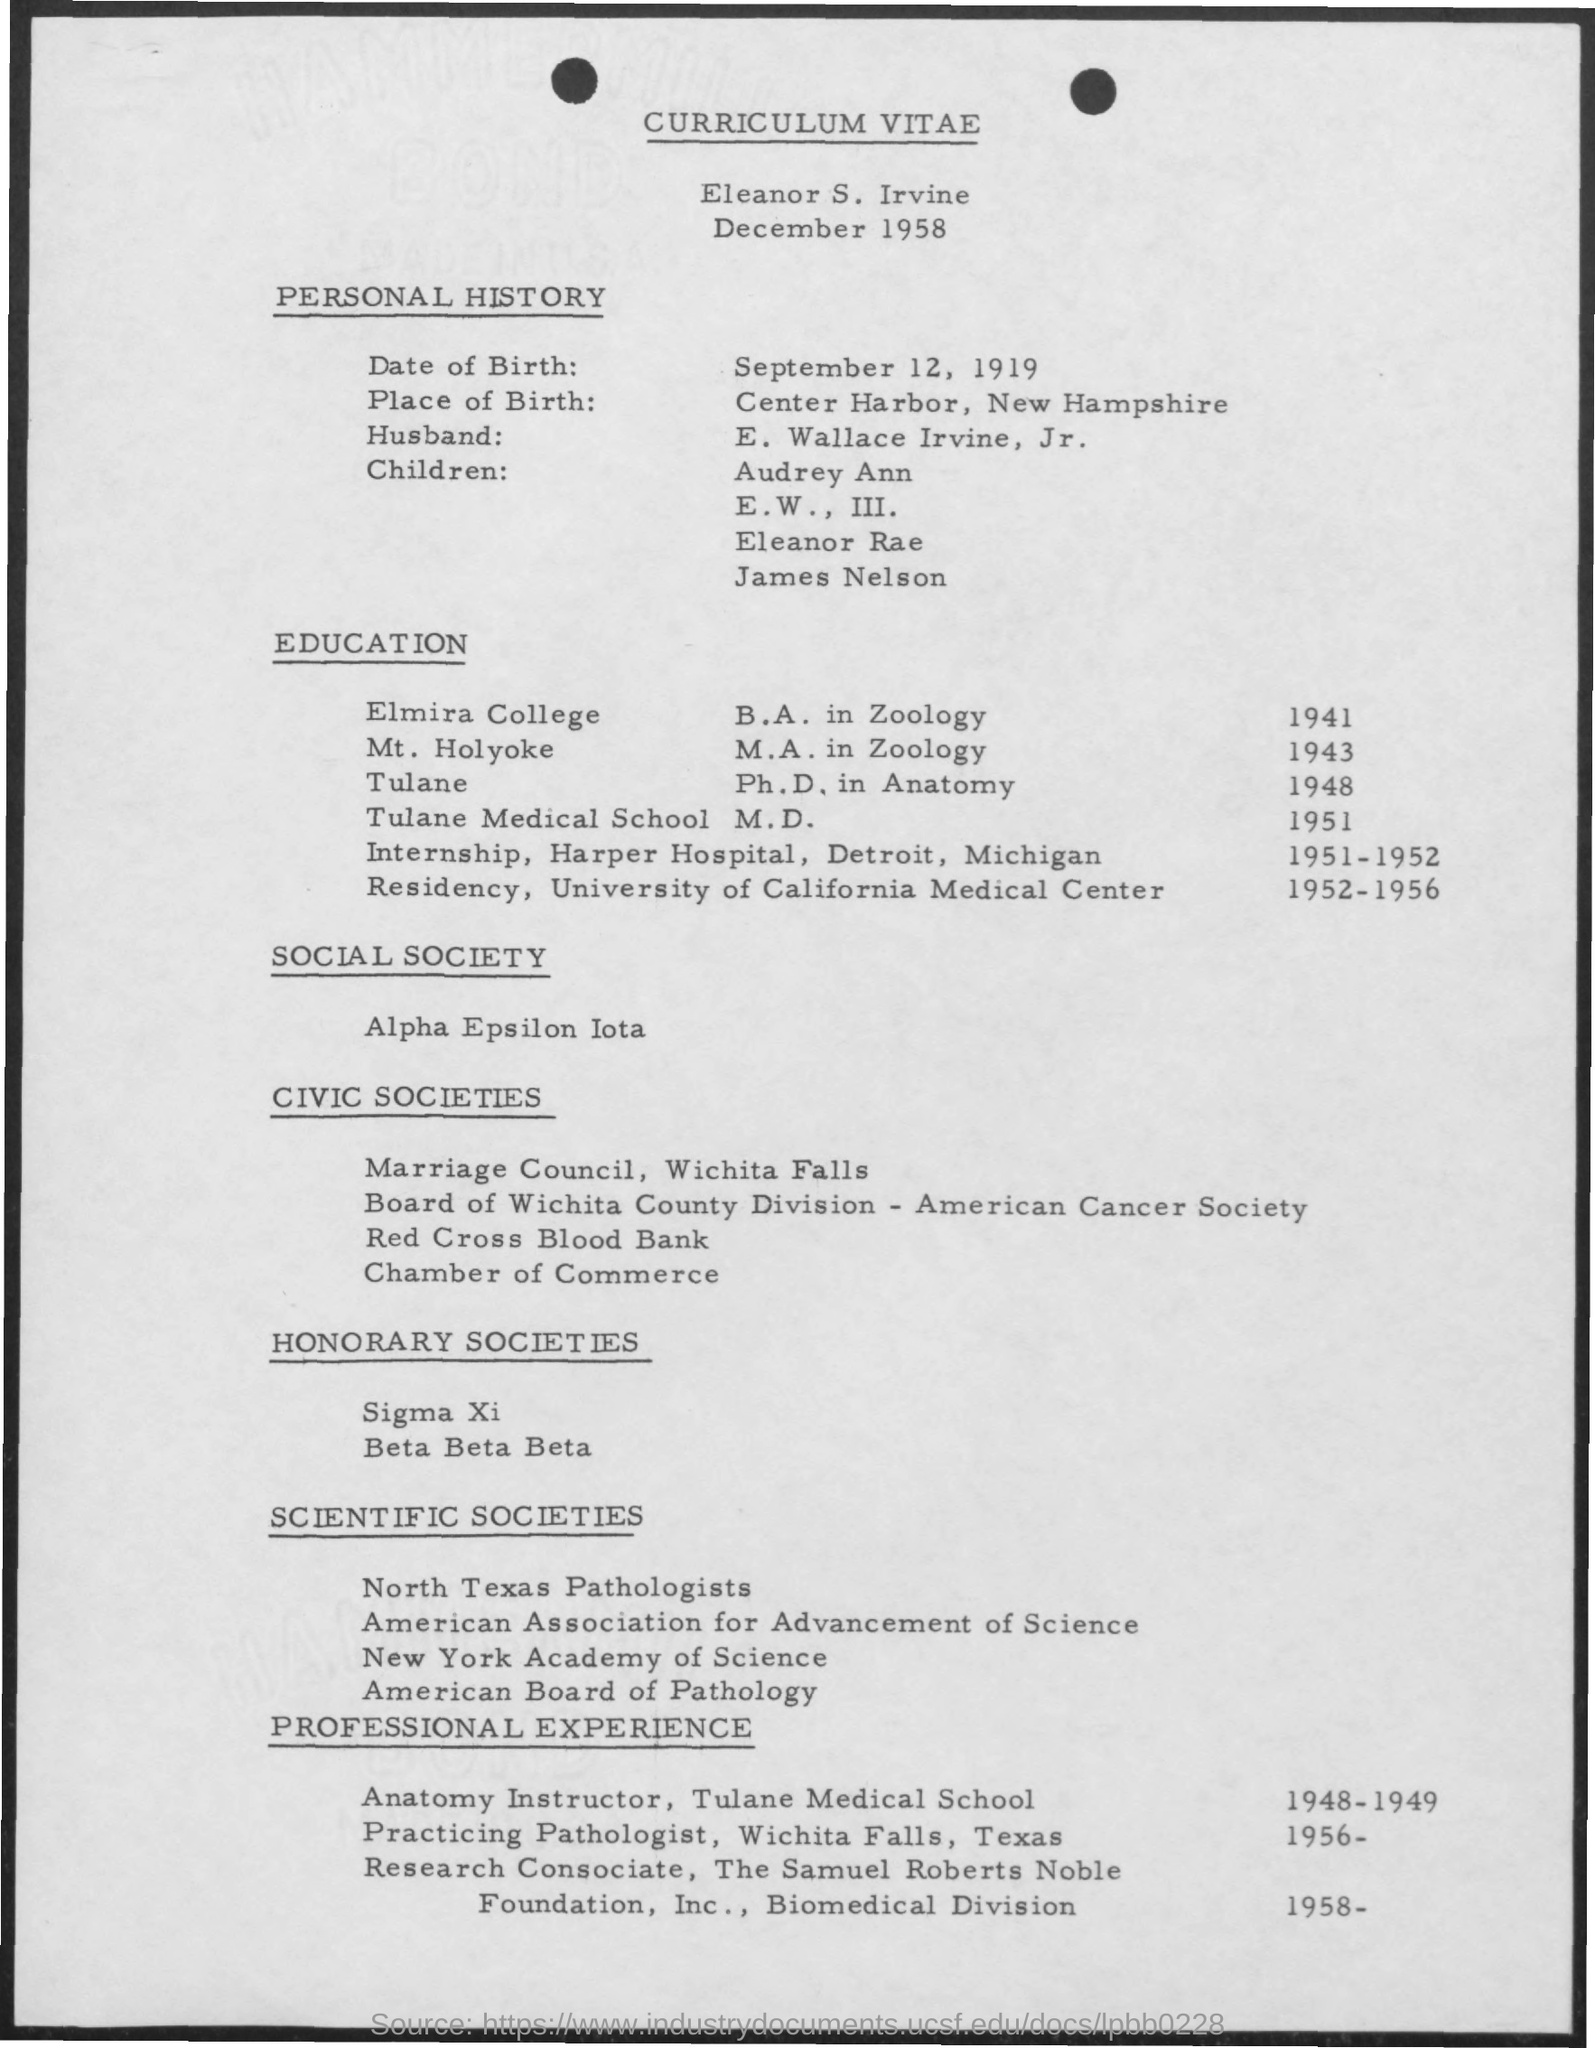Give some essential details in this illustration. The place of birth mentioned on the given page is Center Harbor, New Hampshire. The husband mentioned is E. Wallace Irvine, Jr. The date of birth mentioned in the given page is September 12, 1919. The social society mentioned is called Alpha Epsilon Iota. B.A. was completed at Elmira College. 